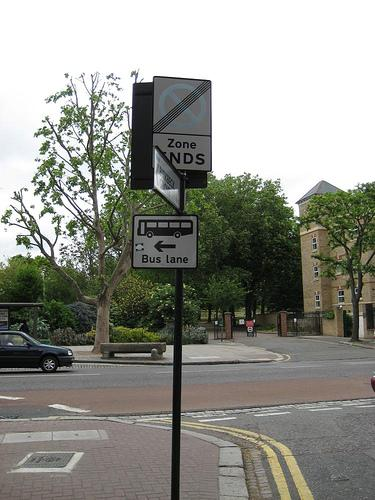What is the sign pointing to? Please explain your reasoning. bus lane. The sign is pointing left to the bus lane. 